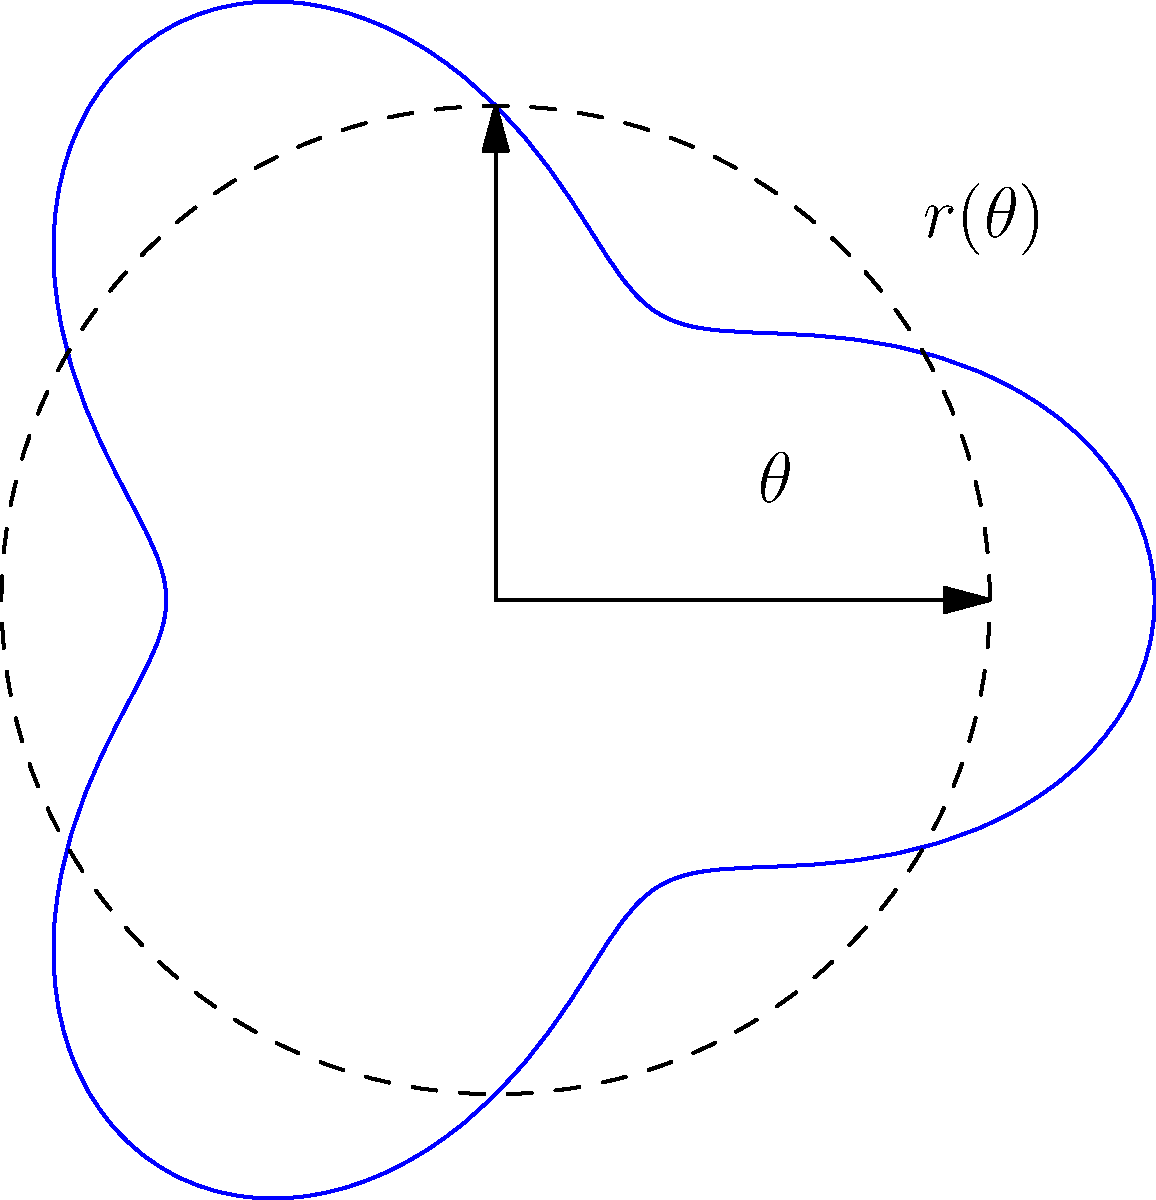A high-performance race car's spoiler angle needs to be optimized for maximum downforce. The effectiveness of the spoiler can be represented by the polar equation $r(\theta) = 3 + \cos(3\theta)$, where $r$ is the downforce (in kN) and $\theta$ is the angle (in radians) from the horizontal. At what angle should the spoiler be set to achieve maximum downforce, and what is this maximum value? To find the maximum downforce and its corresponding angle, we need to follow these steps:

1) The maximum value of $r(\theta)$ will occur when $\cos(3\theta)$ is at its maximum, which is 1.

2) $\cos(3\theta) = 1$ when $3\theta = 0, 2\pi, 4\pi, ...$ or when $\theta = 0, \frac{2\pi}{3}, \frac{4\pi}{3}, ...$

3) In the context of a spoiler angle, we're interested in the first positive angle, which is $\frac{2\pi}{3}$ radians.

4) To convert this to degrees: $\frac{2\pi}{3} \cdot \frac{180^\circ}{\pi} = 120^\circ$

5) The maximum downforce will be:
   $r_{max} = 3 + \cos(3 \cdot \frac{2\pi}{3}) = 3 + 1 = 4$ kN

Therefore, the spoiler should be set at an angle of 120° from the horizontal to achieve the maximum downforce of 4 kN.
Answer: 120°, 4 kN 